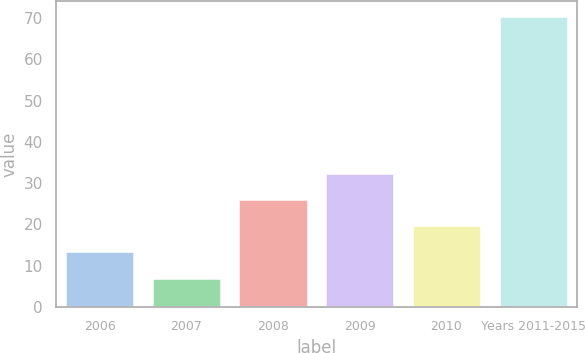Convert chart to OTSL. <chart><loc_0><loc_0><loc_500><loc_500><bar_chart><fcel>2006<fcel>2007<fcel>2008<fcel>2009<fcel>2010<fcel>Years 2011-2015<nl><fcel>13.45<fcel>7.1<fcel>26.15<fcel>32.5<fcel>19.8<fcel>70.6<nl></chart> 